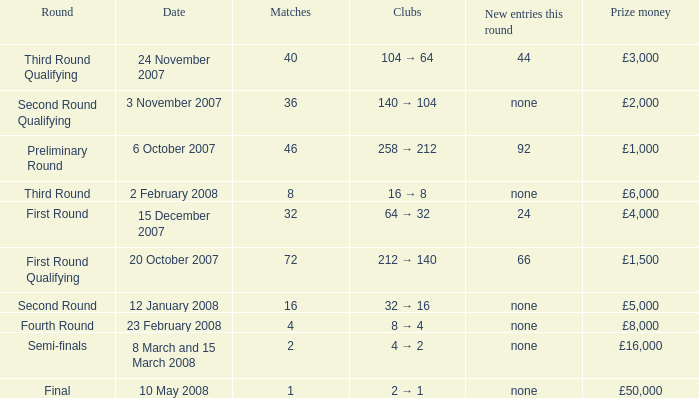How many new entries this round are there with more than 16 matches and a third round qualifying? 44.0. 